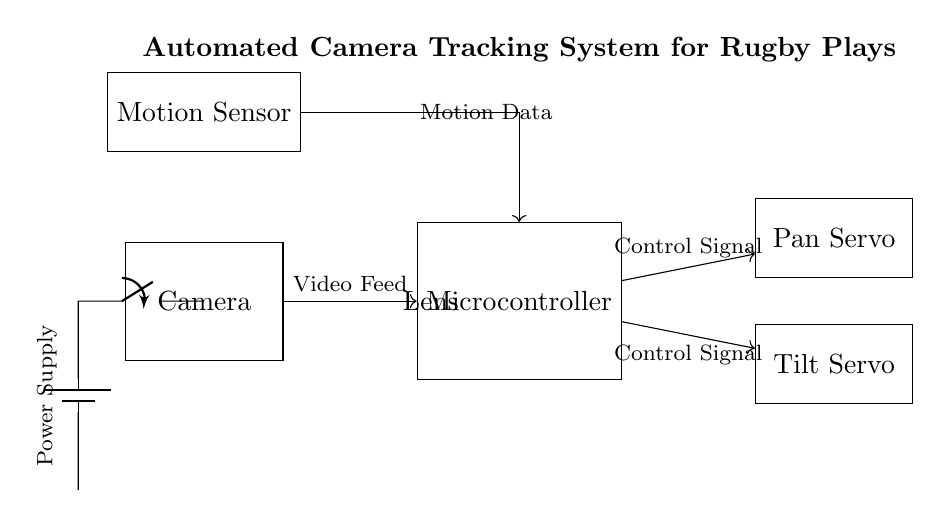What is the main function of the microcontroller? The microcontroller is central to the automated camera tracking system, as it processes the video feed and motion data to generate the control signals for the servos.
Answer: Control signal generation What components are used for movement control? The system uses two servo motors, the pan servo and tilt servo, which are responsible for adjusting the camera's position based on the control signals from the microcontroller.
Answer: Pan servo and tilt servo How does the motion sensor connect to the microcontroller? The motion sensor connects to the microcontroller via a direct routed line that transmits the motion data needed for tracking movements on the field.
Answer: Direct line How many power sources are in this circuit? The circuit features one power source, which is represented by a battery that powers the entire system, including the camera, sensors, and microcontroller.
Answer: One What is the purpose of the battery in this circuit? The battery serves as the power supply for the entire system, providing the necessary voltage and current for the operation of components like the camera, motion sensor, and microcontroller.
Answer: Power supply What type of control signals do the servo motors receive? The servo motors receive control signals that are generated by the microcontroller based on input from the camera and the motion data, enabling them to pan and tilt accordingly.
Answer: Control signals Which component provides the video feed? The camera provides the video feed to the microcontroller, allowing for the processing and tracking of players during the rugby game.
Answer: Camera 